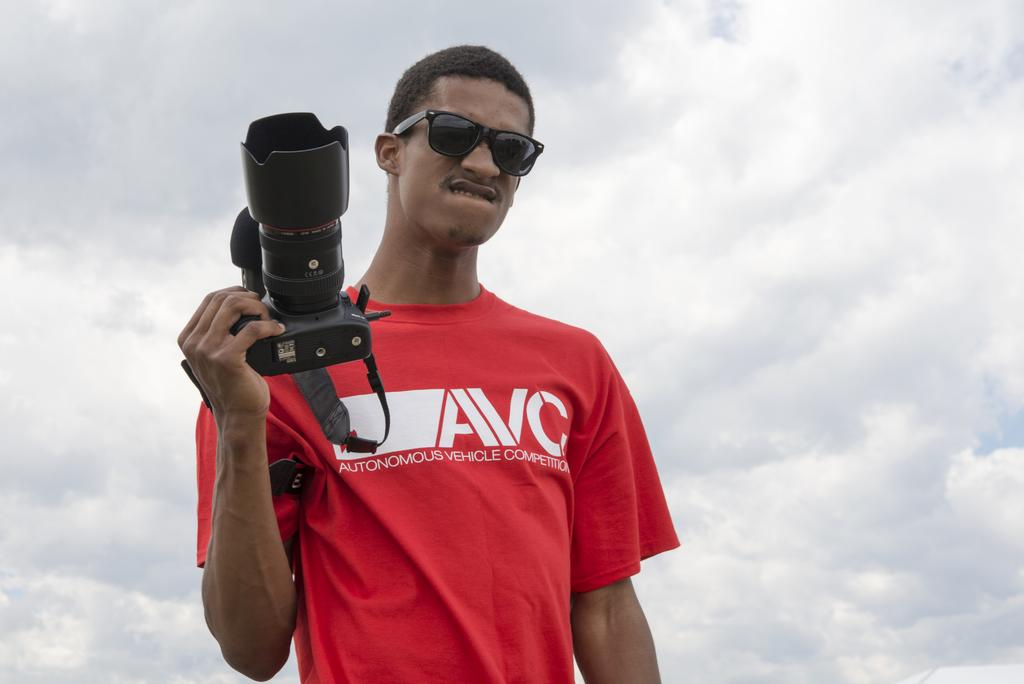Who is in the image? There is a man in the image. What is the man wearing? The man is wearing a red t-shirt. What accessory is the man wearing? The man is wearing glasses. What is the man holding in the image? The man is holding a camera. What can be seen in the background of the image? The sky is visible in the background of the image. What is the weather like in the image? The sky appears to be cloudy, suggesting overcast or potentially rainy weather. What type of lift can be seen in the image? There is no lift present in the image; it features a man holding a camera. Is there a crook in the image? There is no crook present in the image. 